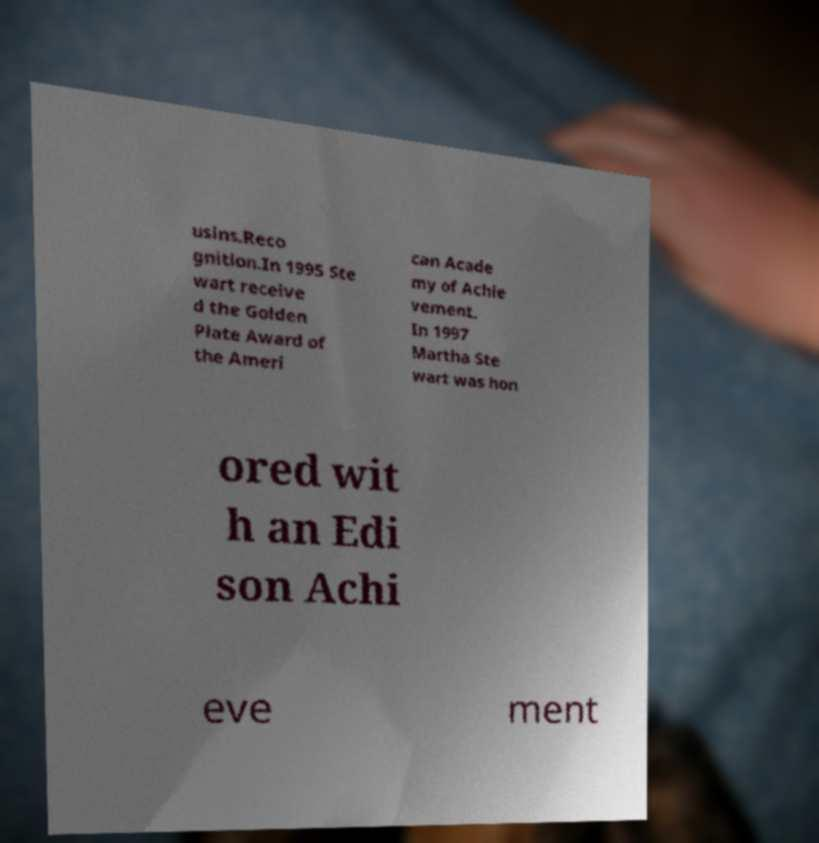For documentation purposes, I need the text within this image transcribed. Could you provide that? usins.Reco gnition.In 1995 Ste wart receive d the Golden Plate Award of the Ameri can Acade my of Achie vement. In 1997 Martha Ste wart was hon ored wit h an Edi son Achi eve ment 